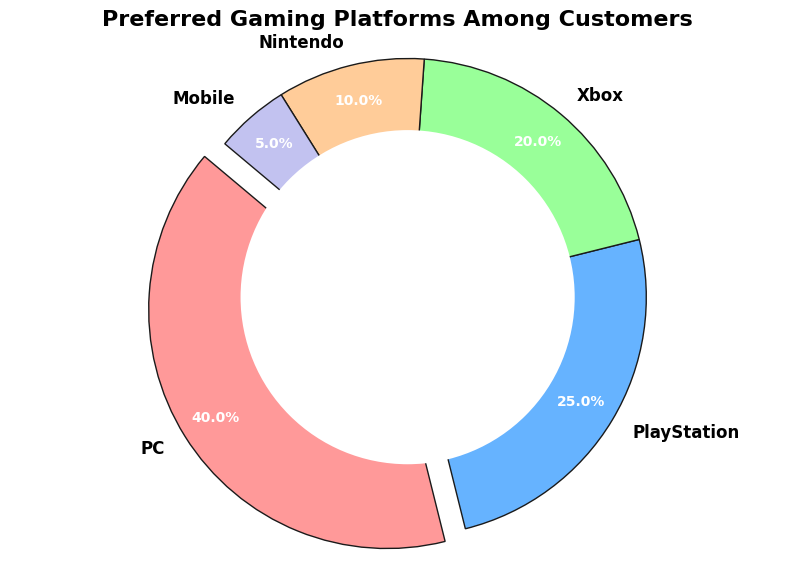What is the most preferred gaming platform among your customers? The pie chart shows that the largest segment is for the PC platform, which occupies 40% of the total chart.
Answer: PC Which gaming platform is preferred by a quarter of your customers? The chart indicates that the segment for PlayStation constitutes 25% of the pie, which is exactly one-quarter of the total.
Answer: PlayStation What is the least preferred gaming platform among your customers? The smallest segment of the pie chart belongs to the Mobile platform, which constitutes 5%.
Answer: Mobile What are the combined percentages of customers preferring Xbox and Nintendo platforms? The pie chart shows that Xbox has 20% and Nintendo has 10%. Adding these together gives 20% + 10% = 30%.
Answer: 30% How does the percentage of customers preferring PlayStation compare to those preferring Xbox? The chart shows that PlayStation has a segment of 25%, while Xbox has 20%. Therefore, PlayStation (25%) is preferred by a higher percentage of customers than Xbox (20%).
Answer: PlayStation is more preferred than Xbox By how much does the percentage of customers preferring PC exceed those preferring Mobile? The pie chart displays that PC has 40% and Mobile has 5%. The difference between these percentages is 40% - 5% = 35%.
Answer: 35% Which segment of the pie chart is colored red? The red-colored segment is the one that represents the PC platform, as it's the largest and highlighted by being the first slice.
Answer: PC 